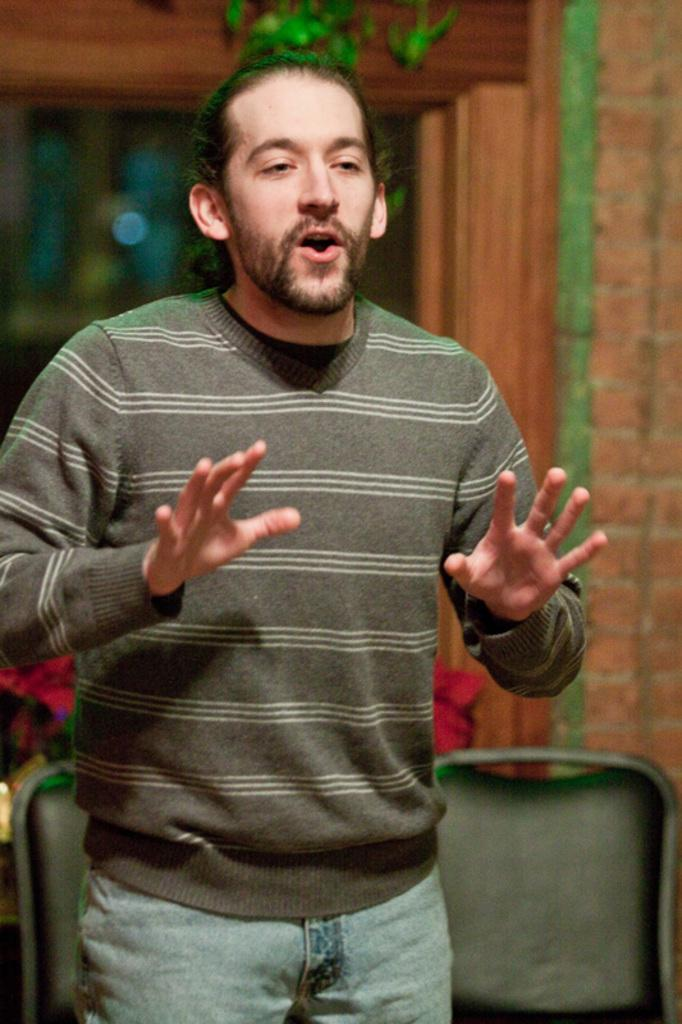Who is present in the image? There is a man in the image. What type of clothing is the man wearing? The man is wearing a sweater and jeans. What can be seen behind the man? There are chairs behind the man. What type of wall is visible in the image? There is a brick wall in the image. Can you see any forks in the image? There are no forks present in the image. Is the man walking along the sea in the image? There is no sea visible in the image, and the man is not walking; he is standing still. 